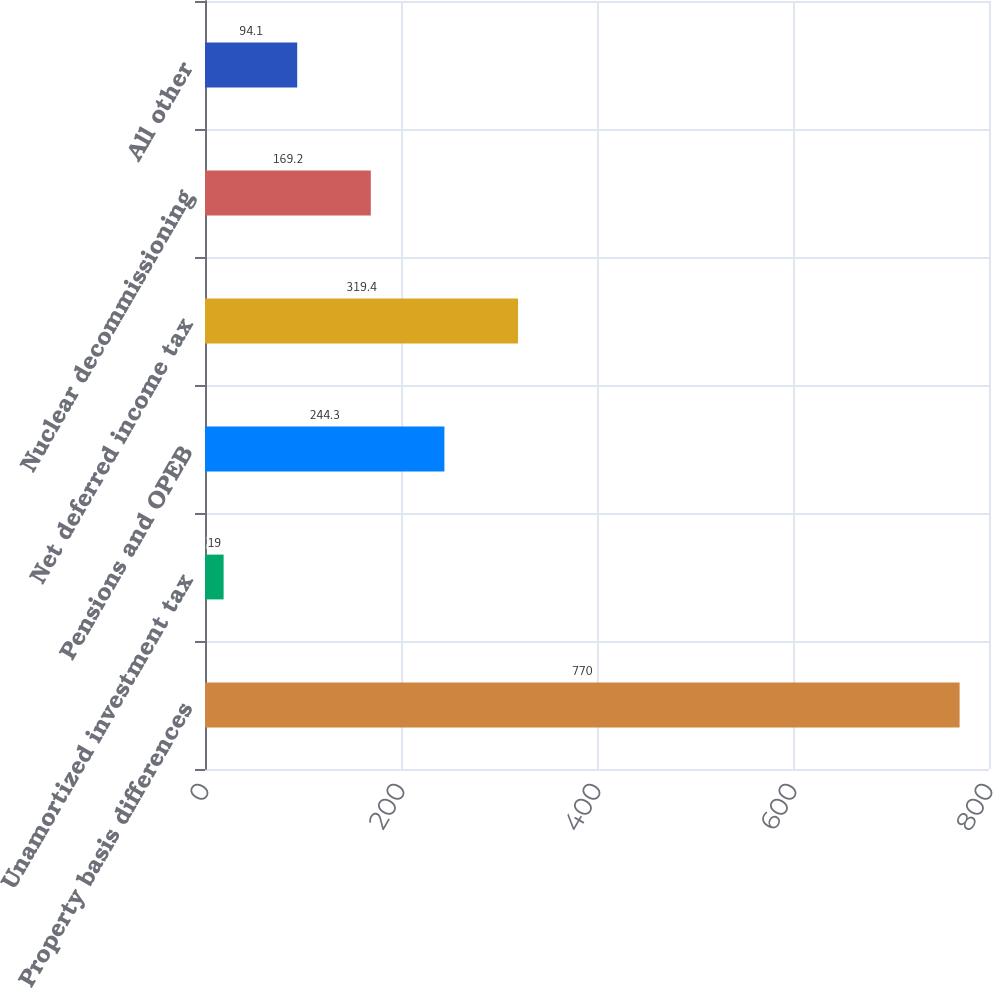<chart> <loc_0><loc_0><loc_500><loc_500><bar_chart><fcel>Property basis differences<fcel>Unamortized investment tax<fcel>Pensions and OPEB<fcel>Net deferred income tax<fcel>Nuclear decommissioning<fcel>All other<nl><fcel>770<fcel>19<fcel>244.3<fcel>319.4<fcel>169.2<fcel>94.1<nl></chart> 